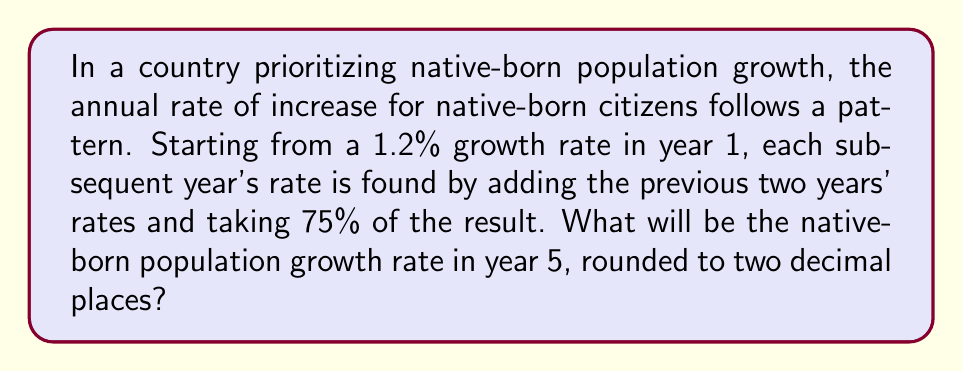Can you solve this math problem? Let's calculate the growth rates step by step:

Year 1: 1.2% (given)

Year 2: 1.2% (assumed to be the same as year 1 for pattern initiation)

Year 3: 
$$(1.2\% + 1.2\%) \times 0.75 = 2.4\% \times 0.75 = 1.8\%$$

Year 4:
$$(1.2\% + 1.8\%) \times 0.75 = 3\% \times 0.75 = 2.25\%$$

Year 5:
$$(1.8\% + 2.25\%) \times 0.75 = 4.05\% \times 0.75 = 3.0375\%$$

Rounding to two decimal places: 3.04%
Answer: 3.04% 